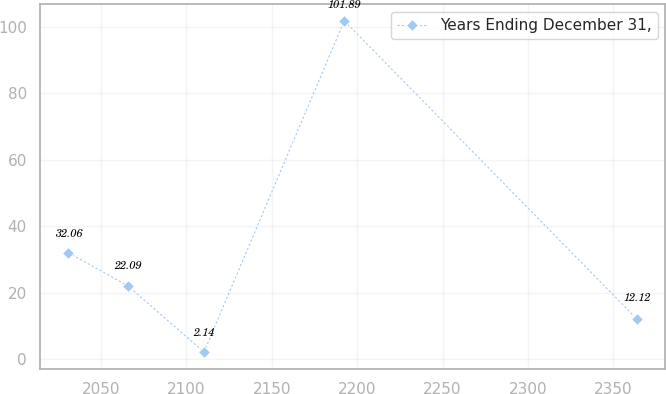Convert chart to OTSL. <chart><loc_0><loc_0><loc_500><loc_500><line_chart><ecel><fcel>Years Ending December 31,<nl><fcel>2031<fcel>32.06<nl><fcel>2065.78<fcel>22.09<nl><fcel>2110.38<fcel>2.14<nl><fcel>2192.5<fcel>101.89<nl><fcel>2363.7<fcel>12.12<nl></chart> 